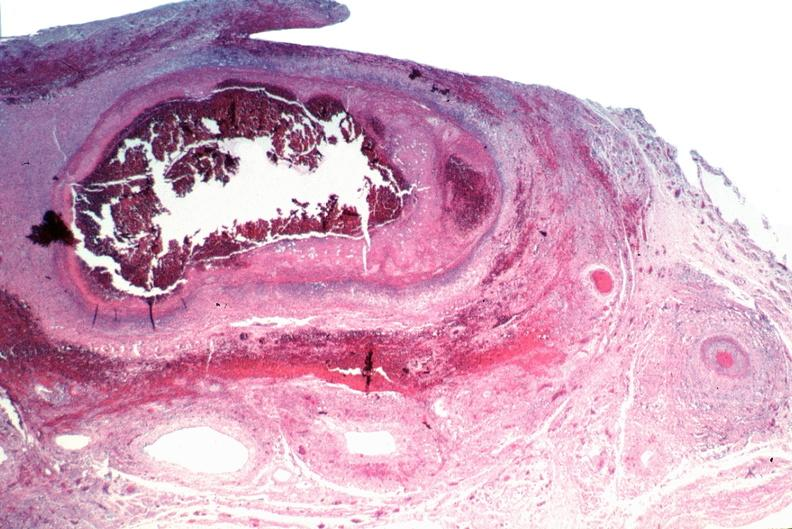does cranial artery show vasculitis, polyarteritis nodosa?
Answer the question using a single word or phrase. No 